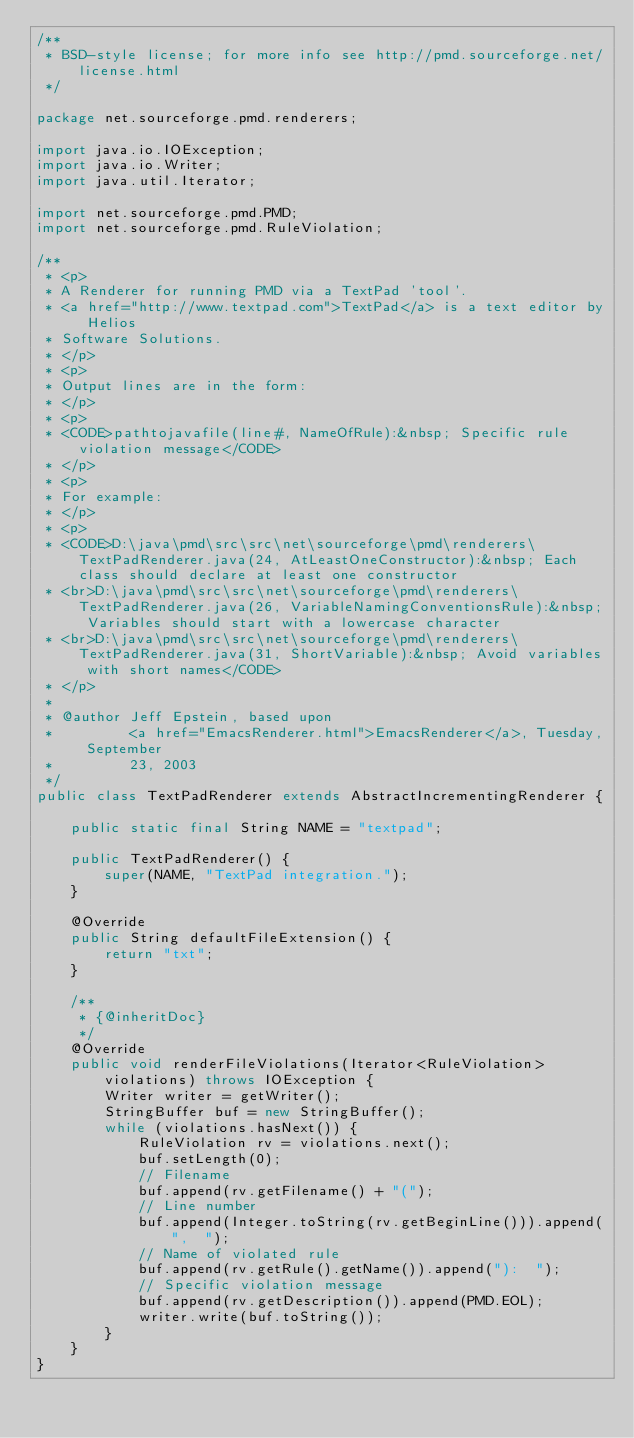Convert code to text. <code><loc_0><loc_0><loc_500><loc_500><_Java_>/**
 * BSD-style license; for more info see http://pmd.sourceforge.net/license.html
 */

package net.sourceforge.pmd.renderers;

import java.io.IOException;
import java.io.Writer;
import java.util.Iterator;

import net.sourceforge.pmd.PMD;
import net.sourceforge.pmd.RuleViolation;

/**
 * <p>
 * A Renderer for running PMD via a TextPad 'tool'.
 * <a href="http://www.textpad.com">TextPad</a> is a text editor by Helios
 * Software Solutions.
 * </p>
 * <p>
 * Output lines are in the form:
 * </p>
 * <p>
 * <CODE>pathtojavafile(line#, NameOfRule):&nbsp; Specific rule violation message</CODE>
 * </p>
 * <p>
 * For example:
 * </p>
 * <p>
 * <CODE>D:\java\pmd\src\src\net\sourceforge\pmd\renderers\TextPadRenderer.java(24, AtLeastOneConstructor):&nbsp; Each class should declare at least one constructor
 * <br>D:\java\pmd\src\src\net\sourceforge\pmd\renderers\TextPadRenderer.java(26, VariableNamingConventionsRule):&nbsp; Variables should start with a lowercase character
 * <br>D:\java\pmd\src\src\net\sourceforge\pmd\renderers\TextPadRenderer.java(31, ShortVariable):&nbsp; Avoid variables with short names</CODE>
 * </p>
 *
 * @author Jeff Epstein, based upon
 *         <a href="EmacsRenderer.html">EmacsRenderer</a>, Tuesday, September
 *         23, 2003
 */
public class TextPadRenderer extends AbstractIncrementingRenderer {

    public static final String NAME = "textpad";

    public TextPadRenderer() {
        super(NAME, "TextPad integration.");
    }

    @Override
    public String defaultFileExtension() {
        return "txt";
    }

    /**
     * {@inheritDoc}
     */
    @Override
    public void renderFileViolations(Iterator<RuleViolation> violations) throws IOException {
        Writer writer = getWriter();
        StringBuffer buf = new StringBuffer();
        while (violations.hasNext()) {
            RuleViolation rv = violations.next();
            buf.setLength(0);
            // Filename
            buf.append(rv.getFilename() + "(");
            // Line number
            buf.append(Integer.toString(rv.getBeginLine())).append(",  ");
            // Name of violated rule
            buf.append(rv.getRule().getName()).append("):  ");
            // Specific violation message
            buf.append(rv.getDescription()).append(PMD.EOL);
            writer.write(buf.toString());
        }
    }
}
</code> 